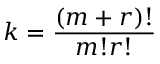<formula> <loc_0><loc_0><loc_500><loc_500>k = \frac { \left ( m + r \right ) ! } { m ! r ! }</formula> 